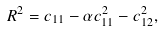<formula> <loc_0><loc_0><loc_500><loc_500>R ^ { 2 } = c _ { 1 1 } - \alpha c _ { 1 1 } ^ { 2 } - c _ { 1 2 } ^ { 2 } ,</formula> 